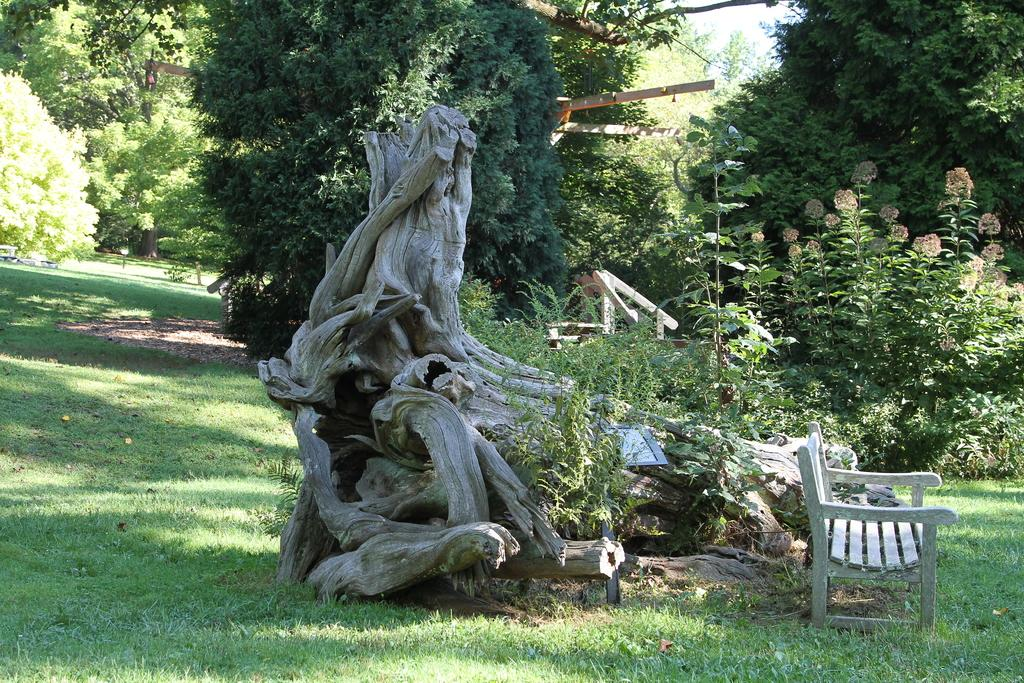What type of vegetation can be seen in the image? There is grass, plants, and trees in the image. What might be a suitable place for people to sit in the image? There is a bench in the image where people could sit. What type of blade is being used by the class in the image? There is no class or blade present in the image; it features grass, plants, trees, and a bench. 